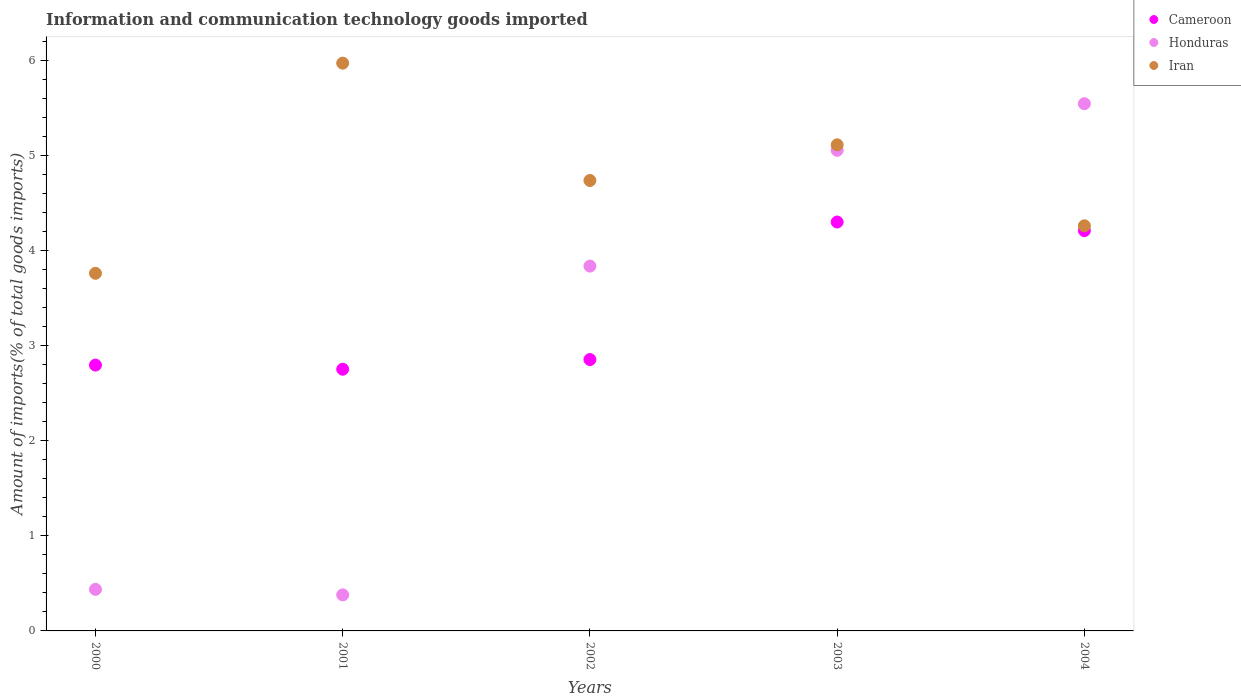Is the number of dotlines equal to the number of legend labels?
Keep it short and to the point. Yes. What is the amount of goods imported in Iran in 2003?
Ensure brevity in your answer.  5.11. Across all years, what is the maximum amount of goods imported in Iran?
Your answer should be compact. 5.97. Across all years, what is the minimum amount of goods imported in Honduras?
Provide a succinct answer. 0.38. In which year was the amount of goods imported in Honduras maximum?
Your answer should be very brief. 2004. What is the total amount of goods imported in Iran in the graph?
Make the answer very short. 23.85. What is the difference between the amount of goods imported in Iran in 2001 and that in 2002?
Your answer should be compact. 1.23. What is the difference between the amount of goods imported in Iran in 2003 and the amount of goods imported in Cameroon in 2000?
Offer a terse response. 2.32. What is the average amount of goods imported in Cameroon per year?
Your response must be concise. 3.38. In the year 2004, what is the difference between the amount of goods imported in Iran and amount of goods imported in Honduras?
Make the answer very short. -1.28. In how many years, is the amount of goods imported in Iran greater than 1.8 %?
Your response must be concise. 5. What is the ratio of the amount of goods imported in Iran in 2003 to that in 2004?
Ensure brevity in your answer.  1.2. What is the difference between the highest and the second highest amount of goods imported in Honduras?
Your response must be concise. 0.49. What is the difference between the highest and the lowest amount of goods imported in Cameroon?
Provide a short and direct response. 1.55. In how many years, is the amount of goods imported in Honduras greater than the average amount of goods imported in Honduras taken over all years?
Make the answer very short. 3. Is the amount of goods imported in Honduras strictly greater than the amount of goods imported in Iran over the years?
Make the answer very short. No. How many dotlines are there?
Keep it short and to the point. 3. How many years are there in the graph?
Keep it short and to the point. 5. What is the difference between two consecutive major ticks on the Y-axis?
Provide a succinct answer. 1. Are the values on the major ticks of Y-axis written in scientific E-notation?
Your answer should be compact. No. Where does the legend appear in the graph?
Your response must be concise. Top right. How many legend labels are there?
Offer a very short reply. 3. What is the title of the graph?
Offer a terse response. Information and communication technology goods imported. Does "Swaziland" appear as one of the legend labels in the graph?
Make the answer very short. No. What is the label or title of the X-axis?
Give a very brief answer. Years. What is the label or title of the Y-axis?
Ensure brevity in your answer.  Amount of imports(% of total goods imports). What is the Amount of imports(% of total goods imports) in Cameroon in 2000?
Give a very brief answer. 2.8. What is the Amount of imports(% of total goods imports) of Honduras in 2000?
Give a very brief answer. 0.44. What is the Amount of imports(% of total goods imports) of Iran in 2000?
Offer a terse response. 3.76. What is the Amount of imports(% of total goods imports) of Cameroon in 2001?
Ensure brevity in your answer.  2.75. What is the Amount of imports(% of total goods imports) in Honduras in 2001?
Offer a very short reply. 0.38. What is the Amount of imports(% of total goods imports) in Iran in 2001?
Your answer should be very brief. 5.97. What is the Amount of imports(% of total goods imports) of Cameroon in 2002?
Ensure brevity in your answer.  2.86. What is the Amount of imports(% of total goods imports) of Honduras in 2002?
Your answer should be very brief. 3.84. What is the Amount of imports(% of total goods imports) in Iran in 2002?
Provide a short and direct response. 4.74. What is the Amount of imports(% of total goods imports) of Cameroon in 2003?
Ensure brevity in your answer.  4.3. What is the Amount of imports(% of total goods imports) in Honduras in 2003?
Provide a short and direct response. 5.06. What is the Amount of imports(% of total goods imports) in Iran in 2003?
Offer a terse response. 5.11. What is the Amount of imports(% of total goods imports) in Cameroon in 2004?
Give a very brief answer. 4.21. What is the Amount of imports(% of total goods imports) of Honduras in 2004?
Make the answer very short. 5.55. What is the Amount of imports(% of total goods imports) in Iran in 2004?
Your answer should be compact. 4.26. Across all years, what is the maximum Amount of imports(% of total goods imports) of Cameroon?
Keep it short and to the point. 4.3. Across all years, what is the maximum Amount of imports(% of total goods imports) in Honduras?
Ensure brevity in your answer.  5.55. Across all years, what is the maximum Amount of imports(% of total goods imports) of Iran?
Keep it short and to the point. 5.97. Across all years, what is the minimum Amount of imports(% of total goods imports) in Cameroon?
Provide a short and direct response. 2.75. Across all years, what is the minimum Amount of imports(% of total goods imports) in Honduras?
Provide a succinct answer. 0.38. Across all years, what is the minimum Amount of imports(% of total goods imports) in Iran?
Provide a short and direct response. 3.76. What is the total Amount of imports(% of total goods imports) of Cameroon in the graph?
Provide a succinct answer. 16.92. What is the total Amount of imports(% of total goods imports) in Honduras in the graph?
Offer a terse response. 15.26. What is the total Amount of imports(% of total goods imports) in Iran in the graph?
Your answer should be very brief. 23.85. What is the difference between the Amount of imports(% of total goods imports) of Cameroon in 2000 and that in 2001?
Your answer should be very brief. 0.04. What is the difference between the Amount of imports(% of total goods imports) of Honduras in 2000 and that in 2001?
Ensure brevity in your answer.  0.06. What is the difference between the Amount of imports(% of total goods imports) in Iran in 2000 and that in 2001?
Make the answer very short. -2.21. What is the difference between the Amount of imports(% of total goods imports) in Cameroon in 2000 and that in 2002?
Provide a short and direct response. -0.06. What is the difference between the Amount of imports(% of total goods imports) of Honduras in 2000 and that in 2002?
Provide a short and direct response. -3.4. What is the difference between the Amount of imports(% of total goods imports) in Iran in 2000 and that in 2002?
Keep it short and to the point. -0.98. What is the difference between the Amount of imports(% of total goods imports) in Cameroon in 2000 and that in 2003?
Offer a terse response. -1.51. What is the difference between the Amount of imports(% of total goods imports) of Honduras in 2000 and that in 2003?
Ensure brevity in your answer.  -4.62. What is the difference between the Amount of imports(% of total goods imports) in Iran in 2000 and that in 2003?
Provide a short and direct response. -1.35. What is the difference between the Amount of imports(% of total goods imports) in Cameroon in 2000 and that in 2004?
Ensure brevity in your answer.  -1.41. What is the difference between the Amount of imports(% of total goods imports) of Honduras in 2000 and that in 2004?
Offer a terse response. -5.11. What is the difference between the Amount of imports(% of total goods imports) in Iran in 2000 and that in 2004?
Your response must be concise. -0.5. What is the difference between the Amount of imports(% of total goods imports) of Cameroon in 2001 and that in 2002?
Your answer should be compact. -0.1. What is the difference between the Amount of imports(% of total goods imports) of Honduras in 2001 and that in 2002?
Provide a succinct answer. -3.46. What is the difference between the Amount of imports(% of total goods imports) in Iran in 2001 and that in 2002?
Provide a succinct answer. 1.23. What is the difference between the Amount of imports(% of total goods imports) of Cameroon in 2001 and that in 2003?
Offer a very short reply. -1.55. What is the difference between the Amount of imports(% of total goods imports) in Honduras in 2001 and that in 2003?
Your response must be concise. -4.68. What is the difference between the Amount of imports(% of total goods imports) of Iran in 2001 and that in 2003?
Make the answer very short. 0.86. What is the difference between the Amount of imports(% of total goods imports) in Cameroon in 2001 and that in 2004?
Your answer should be compact. -1.46. What is the difference between the Amount of imports(% of total goods imports) of Honduras in 2001 and that in 2004?
Give a very brief answer. -5.17. What is the difference between the Amount of imports(% of total goods imports) in Iran in 2001 and that in 2004?
Keep it short and to the point. 1.71. What is the difference between the Amount of imports(% of total goods imports) in Cameroon in 2002 and that in 2003?
Ensure brevity in your answer.  -1.45. What is the difference between the Amount of imports(% of total goods imports) of Honduras in 2002 and that in 2003?
Ensure brevity in your answer.  -1.22. What is the difference between the Amount of imports(% of total goods imports) in Iran in 2002 and that in 2003?
Offer a terse response. -0.38. What is the difference between the Amount of imports(% of total goods imports) in Cameroon in 2002 and that in 2004?
Your answer should be compact. -1.36. What is the difference between the Amount of imports(% of total goods imports) of Honduras in 2002 and that in 2004?
Make the answer very short. -1.71. What is the difference between the Amount of imports(% of total goods imports) of Iran in 2002 and that in 2004?
Offer a very short reply. 0.48. What is the difference between the Amount of imports(% of total goods imports) in Cameroon in 2003 and that in 2004?
Offer a terse response. 0.09. What is the difference between the Amount of imports(% of total goods imports) of Honduras in 2003 and that in 2004?
Keep it short and to the point. -0.49. What is the difference between the Amount of imports(% of total goods imports) of Iran in 2003 and that in 2004?
Ensure brevity in your answer.  0.85. What is the difference between the Amount of imports(% of total goods imports) of Cameroon in 2000 and the Amount of imports(% of total goods imports) of Honduras in 2001?
Keep it short and to the point. 2.42. What is the difference between the Amount of imports(% of total goods imports) in Cameroon in 2000 and the Amount of imports(% of total goods imports) in Iran in 2001?
Offer a very short reply. -3.18. What is the difference between the Amount of imports(% of total goods imports) in Honduras in 2000 and the Amount of imports(% of total goods imports) in Iran in 2001?
Offer a very short reply. -5.54. What is the difference between the Amount of imports(% of total goods imports) of Cameroon in 2000 and the Amount of imports(% of total goods imports) of Honduras in 2002?
Your answer should be very brief. -1.04. What is the difference between the Amount of imports(% of total goods imports) of Cameroon in 2000 and the Amount of imports(% of total goods imports) of Iran in 2002?
Provide a succinct answer. -1.94. What is the difference between the Amount of imports(% of total goods imports) in Honduras in 2000 and the Amount of imports(% of total goods imports) in Iran in 2002?
Provide a succinct answer. -4.3. What is the difference between the Amount of imports(% of total goods imports) of Cameroon in 2000 and the Amount of imports(% of total goods imports) of Honduras in 2003?
Offer a very short reply. -2.26. What is the difference between the Amount of imports(% of total goods imports) in Cameroon in 2000 and the Amount of imports(% of total goods imports) in Iran in 2003?
Your response must be concise. -2.32. What is the difference between the Amount of imports(% of total goods imports) of Honduras in 2000 and the Amount of imports(% of total goods imports) of Iran in 2003?
Keep it short and to the point. -4.68. What is the difference between the Amount of imports(% of total goods imports) in Cameroon in 2000 and the Amount of imports(% of total goods imports) in Honduras in 2004?
Your answer should be compact. -2.75. What is the difference between the Amount of imports(% of total goods imports) in Cameroon in 2000 and the Amount of imports(% of total goods imports) in Iran in 2004?
Your answer should be compact. -1.47. What is the difference between the Amount of imports(% of total goods imports) in Honduras in 2000 and the Amount of imports(% of total goods imports) in Iran in 2004?
Give a very brief answer. -3.83. What is the difference between the Amount of imports(% of total goods imports) of Cameroon in 2001 and the Amount of imports(% of total goods imports) of Honduras in 2002?
Offer a very short reply. -1.09. What is the difference between the Amount of imports(% of total goods imports) of Cameroon in 2001 and the Amount of imports(% of total goods imports) of Iran in 2002?
Your response must be concise. -1.99. What is the difference between the Amount of imports(% of total goods imports) of Honduras in 2001 and the Amount of imports(% of total goods imports) of Iran in 2002?
Offer a very short reply. -4.36. What is the difference between the Amount of imports(% of total goods imports) of Cameroon in 2001 and the Amount of imports(% of total goods imports) of Honduras in 2003?
Give a very brief answer. -2.3. What is the difference between the Amount of imports(% of total goods imports) in Cameroon in 2001 and the Amount of imports(% of total goods imports) in Iran in 2003?
Keep it short and to the point. -2.36. What is the difference between the Amount of imports(% of total goods imports) in Honduras in 2001 and the Amount of imports(% of total goods imports) in Iran in 2003?
Keep it short and to the point. -4.74. What is the difference between the Amount of imports(% of total goods imports) of Cameroon in 2001 and the Amount of imports(% of total goods imports) of Honduras in 2004?
Ensure brevity in your answer.  -2.79. What is the difference between the Amount of imports(% of total goods imports) of Cameroon in 2001 and the Amount of imports(% of total goods imports) of Iran in 2004?
Give a very brief answer. -1.51. What is the difference between the Amount of imports(% of total goods imports) of Honduras in 2001 and the Amount of imports(% of total goods imports) of Iran in 2004?
Provide a short and direct response. -3.88. What is the difference between the Amount of imports(% of total goods imports) of Cameroon in 2002 and the Amount of imports(% of total goods imports) of Honduras in 2003?
Offer a terse response. -2.2. What is the difference between the Amount of imports(% of total goods imports) of Cameroon in 2002 and the Amount of imports(% of total goods imports) of Iran in 2003?
Make the answer very short. -2.26. What is the difference between the Amount of imports(% of total goods imports) in Honduras in 2002 and the Amount of imports(% of total goods imports) in Iran in 2003?
Your response must be concise. -1.28. What is the difference between the Amount of imports(% of total goods imports) in Cameroon in 2002 and the Amount of imports(% of total goods imports) in Honduras in 2004?
Provide a short and direct response. -2.69. What is the difference between the Amount of imports(% of total goods imports) in Cameroon in 2002 and the Amount of imports(% of total goods imports) in Iran in 2004?
Provide a short and direct response. -1.41. What is the difference between the Amount of imports(% of total goods imports) of Honduras in 2002 and the Amount of imports(% of total goods imports) of Iran in 2004?
Provide a short and direct response. -0.42. What is the difference between the Amount of imports(% of total goods imports) in Cameroon in 2003 and the Amount of imports(% of total goods imports) in Honduras in 2004?
Your answer should be very brief. -1.25. What is the difference between the Amount of imports(% of total goods imports) in Cameroon in 2003 and the Amount of imports(% of total goods imports) in Iran in 2004?
Your answer should be compact. 0.04. What is the difference between the Amount of imports(% of total goods imports) in Honduras in 2003 and the Amount of imports(% of total goods imports) in Iran in 2004?
Keep it short and to the point. 0.79. What is the average Amount of imports(% of total goods imports) of Cameroon per year?
Ensure brevity in your answer.  3.38. What is the average Amount of imports(% of total goods imports) of Honduras per year?
Your response must be concise. 3.05. What is the average Amount of imports(% of total goods imports) of Iran per year?
Ensure brevity in your answer.  4.77. In the year 2000, what is the difference between the Amount of imports(% of total goods imports) in Cameroon and Amount of imports(% of total goods imports) in Honduras?
Your response must be concise. 2.36. In the year 2000, what is the difference between the Amount of imports(% of total goods imports) in Cameroon and Amount of imports(% of total goods imports) in Iran?
Keep it short and to the point. -0.97. In the year 2000, what is the difference between the Amount of imports(% of total goods imports) in Honduras and Amount of imports(% of total goods imports) in Iran?
Provide a succinct answer. -3.33. In the year 2001, what is the difference between the Amount of imports(% of total goods imports) in Cameroon and Amount of imports(% of total goods imports) in Honduras?
Your answer should be very brief. 2.37. In the year 2001, what is the difference between the Amount of imports(% of total goods imports) in Cameroon and Amount of imports(% of total goods imports) in Iran?
Give a very brief answer. -3.22. In the year 2001, what is the difference between the Amount of imports(% of total goods imports) in Honduras and Amount of imports(% of total goods imports) in Iran?
Your answer should be very brief. -5.59. In the year 2002, what is the difference between the Amount of imports(% of total goods imports) in Cameroon and Amount of imports(% of total goods imports) in Honduras?
Give a very brief answer. -0.98. In the year 2002, what is the difference between the Amount of imports(% of total goods imports) in Cameroon and Amount of imports(% of total goods imports) in Iran?
Your response must be concise. -1.88. In the year 2002, what is the difference between the Amount of imports(% of total goods imports) of Honduras and Amount of imports(% of total goods imports) of Iran?
Offer a terse response. -0.9. In the year 2003, what is the difference between the Amount of imports(% of total goods imports) in Cameroon and Amount of imports(% of total goods imports) in Honduras?
Your response must be concise. -0.75. In the year 2003, what is the difference between the Amount of imports(% of total goods imports) of Cameroon and Amount of imports(% of total goods imports) of Iran?
Offer a very short reply. -0.81. In the year 2003, what is the difference between the Amount of imports(% of total goods imports) in Honduras and Amount of imports(% of total goods imports) in Iran?
Keep it short and to the point. -0.06. In the year 2004, what is the difference between the Amount of imports(% of total goods imports) of Cameroon and Amount of imports(% of total goods imports) of Honduras?
Provide a succinct answer. -1.34. In the year 2004, what is the difference between the Amount of imports(% of total goods imports) in Cameroon and Amount of imports(% of total goods imports) in Iran?
Make the answer very short. -0.05. In the year 2004, what is the difference between the Amount of imports(% of total goods imports) of Honduras and Amount of imports(% of total goods imports) of Iran?
Offer a very short reply. 1.28. What is the ratio of the Amount of imports(% of total goods imports) in Cameroon in 2000 to that in 2001?
Your answer should be compact. 1.02. What is the ratio of the Amount of imports(% of total goods imports) of Honduras in 2000 to that in 2001?
Ensure brevity in your answer.  1.15. What is the ratio of the Amount of imports(% of total goods imports) in Iran in 2000 to that in 2001?
Offer a terse response. 0.63. What is the ratio of the Amount of imports(% of total goods imports) of Cameroon in 2000 to that in 2002?
Provide a short and direct response. 0.98. What is the ratio of the Amount of imports(% of total goods imports) in Honduras in 2000 to that in 2002?
Provide a succinct answer. 0.11. What is the ratio of the Amount of imports(% of total goods imports) of Iran in 2000 to that in 2002?
Give a very brief answer. 0.79. What is the ratio of the Amount of imports(% of total goods imports) of Cameroon in 2000 to that in 2003?
Your answer should be very brief. 0.65. What is the ratio of the Amount of imports(% of total goods imports) in Honduras in 2000 to that in 2003?
Your response must be concise. 0.09. What is the ratio of the Amount of imports(% of total goods imports) in Iran in 2000 to that in 2003?
Give a very brief answer. 0.74. What is the ratio of the Amount of imports(% of total goods imports) of Cameroon in 2000 to that in 2004?
Make the answer very short. 0.66. What is the ratio of the Amount of imports(% of total goods imports) of Honduras in 2000 to that in 2004?
Offer a terse response. 0.08. What is the ratio of the Amount of imports(% of total goods imports) of Iran in 2000 to that in 2004?
Give a very brief answer. 0.88. What is the ratio of the Amount of imports(% of total goods imports) in Cameroon in 2001 to that in 2002?
Provide a succinct answer. 0.96. What is the ratio of the Amount of imports(% of total goods imports) of Honduras in 2001 to that in 2002?
Offer a very short reply. 0.1. What is the ratio of the Amount of imports(% of total goods imports) of Iran in 2001 to that in 2002?
Keep it short and to the point. 1.26. What is the ratio of the Amount of imports(% of total goods imports) in Cameroon in 2001 to that in 2003?
Offer a terse response. 0.64. What is the ratio of the Amount of imports(% of total goods imports) of Honduras in 2001 to that in 2003?
Provide a short and direct response. 0.07. What is the ratio of the Amount of imports(% of total goods imports) of Iran in 2001 to that in 2003?
Make the answer very short. 1.17. What is the ratio of the Amount of imports(% of total goods imports) of Cameroon in 2001 to that in 2004?
Give a very brief answer. 0.65. What is the ratio of the Amount of imports(% of total goods imports) in Honduras in 2001 to that in 2004?
Provide a succinct answer. 0.07. What is the ratio of the Amount of imports(% of total goods imports) in Iran in 2001 to that in 2004?
Your answer should be very brief. 1.4. What is the ratio of the Amount of imports(% of total goods imports) of Cameroon in 2002 to that in 2003?
Make the answer very short. 0.66. What is the ratio of the Amount of imports(% of total goods imports) in Honduras in 2002 to that in 2003?
Offer a terse response. 0.76. What is the ratio of the Amount of imports(% of total goods imports) in Iran in 2002 to that in 2003?
Your answer should be very brief. 0.93. What is the ratio of the Amount of imports(% of total goods imports) in Cameroon in 2002 to that in 2004?
Ensure brevity in your answer.  0.68. What is the ratio of the Amount of imports(% of total goods imports) of Honduras in 2002 to that in 2004?
Your response must be concise. 0.69. What is the ratio of the Amount of imports(% of total goods imports) of Iran in 2002 to that in 2004?
Your answer should be very brief. 1.11. What is the ratio of the Amount of imports(% of total goods imports) in Cameroon in 2003 to that in 2004?
Offer a very short reply. 1.02. What is the ratio of the Amount of imports(% of total goods imports) of Honduras in 2003 to that in 2004?
Your answer should be compact. 0.91. What is the ratio of the Amount of imports(% of total goods imports) in Iran in 2003 to that in 2004?
Offer a terse response. 1.2. What is the difference between the highest and the second highest Amount of imports(% of total goods imports) in Cameroon?
Your response must be concise. 0.09. What is the difference between the highest and the second highest Amount of imports(% of total goods imports) of Honduras?
Your answer should be compact. 0.49. What is the difference between the highest and the second highest Amount of imports(% of total goods imports) of Iran?
Provide a succinct answer. 0.86. What is the difference between the highest and the lowest Amount of imports(% of total goods imports) in Cameroon?
Give a very brief answer. 1.55. What is the difference between the highest and the lowest Amount of imports(% of total goods imports) of Honduras?
Ensure brevity in your answer.  5.17. What is the difference between the highest and the lowest Amount of imports(% of total goods imports) of Iran?
Keep it short and to the point. 2.21. 